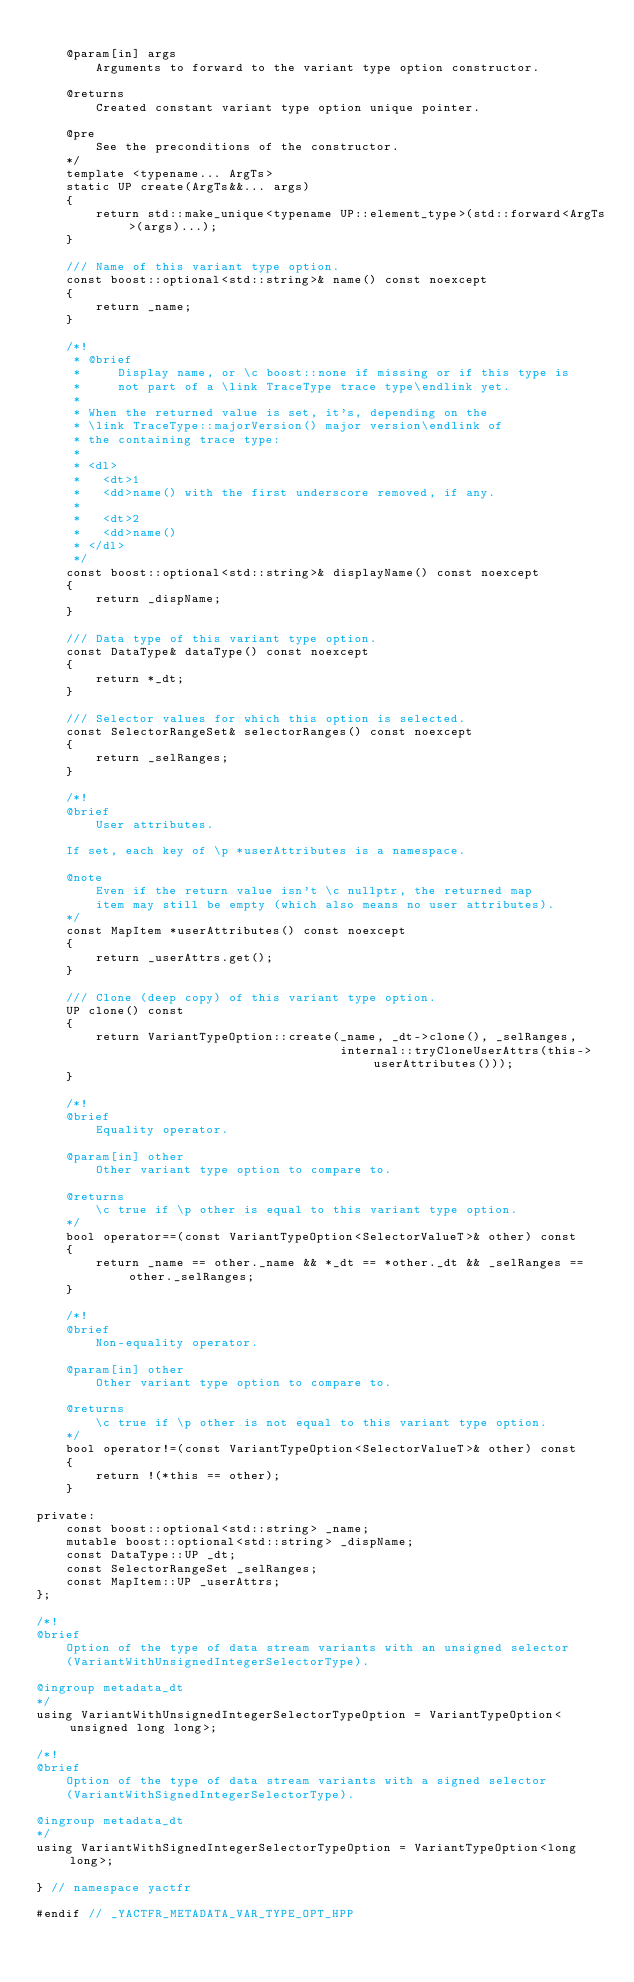Convert code to text. <code><loc_0><loc_0><loc_500><loc_500><_C++_>
    @param[in] args
        Arguments to forward to the variant type option constructor.

    @returns
        Created constant variant type option unique pointer.

    @pre
        See the preconditions of the constructor.
    */
    template <typename... ArgTs>
    static UP create(ArgTs&&... args)
    {
        return std::make_unique<typename UP::element_type>(std::forward<ArgTs>(args)...);
    }

    /// Name of this variant type option.
    const boost::optional<std::string>& name() const noexcept
    {
        return _name;
    }

    /*!
     * @brief
     *     Display name, or \c boost::none if missing or if this type is
     *     not part of a \link TraceType trace type\endlink yet.
     *
     * When the returned value is set, it's, depending on the
     * \link TraceType::majorVersion() major version\endlink of
     * the containing trace type:
     *
     * <dl>
     *   <dt>1
     *   <dd>name() with the first underscore removed, if any.
     *
     *   <dt>2
     *   <dd>name()
     * </dl>
     */
    const boost::optional<std::string>& displayName() const noexcept
    {
        return _dispName;
    }

    /// Data type of this variant type option.
    const DataType& dataType() const noexcept
    {
        return *_dt;
    }

    /// Selector values for which this option is selected.
    const SelectorRangeSet& selectorRanges() const noexcept
    {
        return _selRanges;
    }

    /*!
    @brief
        User attributes.

    If set, each key of \p *userAttributes is a namespace.

    @note
        Even if the return value isn't \c nullptr, the returned map
        item may still be empty (which also means no user attributes).
    */
    const MapItem *userAttributes() const noexcept
    {
        return _userAttrs.get();
    }

    /// Clone (deep copy) of this variant type option.
    UP clone() const
    {
        return VariantTypeOption::create(_name, _dt->clone(), _selRanges,
                                         internal::tryCloneUserAttrs(this->userAttributes()));
    }

    /*!
    @brief
        Equality operator.

    @param[in] other
        Other variant type option to compare to.

    @returns
        \c true if \p other is equal to this variant type option.
    */
    bool operator==(const VariantTypeOption<SelectorValueT>& other) const
    {
        return _name == other._name && *_dt == *other._dt && _selRanges == other._selRanges;
    }

    /*!
    @brief
        Non-equality operator.

    @param[in] other
        Other variant type option to compare to.

    @returns
        \c true if \p other is not equal to this variant type option.
    */
    bool operator!=(const VariantTypeOption<SelectorValueT>& other) const
    {
        return !(*this == other);
    }

private:
    const boost::optional<std::string> _name;
    mutable boost::optional<std::string> _dispName;
    const DataType::UP _dt;
    const SelectorRangeSet _selRanges;
    const MapItem::UP _userAttrs;
};

/*!
@brief
    Option of the type of data stream variants with an unsigned selector
    (VariantWithUnsignedIntegerSelectorType).

@ingroup metadata_dt
*/
using VariantWithUnsignedIntegerSelectorTypeOption = VariantTypeOption<unsigned long long>;

/*!
@brief
    Option of the type of data stream variants with a signed selector
    (VariantWithSignedIntegerSelectorType).

@ingroup metadata_dt
*/
using VariantWithSignedIntegerSelectorTypeOption = VariantTypeOption<long long>;

} // namespace yactfr

#endif // _YACTFR_METADATA_VAR_TYPE_OPT_HPP
</code> 